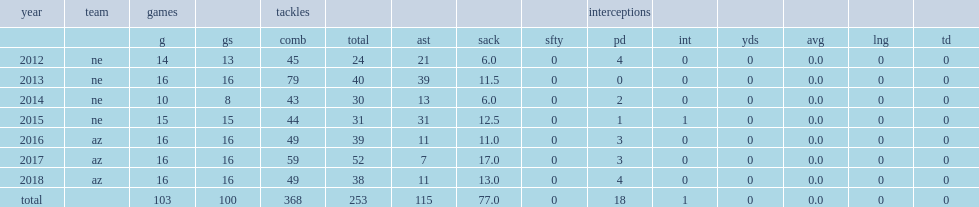How many sacks did jones get in 2013? 11.5. Parse the full table. {'header': ['year', 'team', 'games', '', 'tackles', '', '', '', '', 'interceptions', '', '', '', '', ''], 'rows': [['', '', 'g', 'gs', 'comb', 'total', 'ast', 'sack', 'sfty', 'pd', 'int', 'yds', 'avg', 'lng', 'td'], ['2012', 'ne', '14', '13', '45', '24', '21', '6.0', '0', '4', '0', '0', '0.0', '0', '0'], ['2013', 'ne', '16', '16', '79', '40', '39', '11.5', '0', '0', '0', '0', '0.0', '0', '0'], ['2014', 'ne', '10', '8', '43', '30', '13', '6.0', '0', '2', '0', '0', '0.0', '0', '0'], ['2015', 'ne', '15', '15', '44', '31', '31', '12.5', '0', '1', '1', '0', '0.0', '0', '0'], ['2016', 'az', '16', '16', '49', '39', '11', '11.0', '0', '3', '0', '0', '0.0', '0', '0'], ['2017', 'az', '16', '16', '59', '52', '7', '17.0', '0', '3', '0', '0', '0.0', '0', '0'], ['2018', 'az', '16', '16', '49', '38', '11', '13.0', '0', '4', '0', '0', '0.0', '0', '0'], ['total', '', '103', '100', '368', '253', '115', '77.0', '0', '18', '1', '0', '0.0', '0', '0']]} 